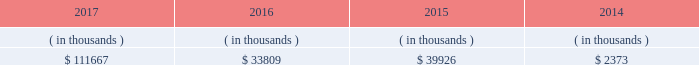System energy may refinance , redeem , or otherwise retire debt prior to maturity , to the extent market conditions and interest and dividend rates are favorable .
All debt and common stock issuances by system energy require prior regulatory approval . a0 a0debt issuances are also subject to issuance tests set forth in its bond indentures and other agreements . a0 a0system energy has sufficient capacity under these tests to meet its foreseeable capital needs .
System energy 2019s receivables from the money pool were as follows as of december 31 for each of the following years. .
See note 4 to the financial statements for a description of the money pool .
The system energy nuclear fuel company variable interest entity has a credit facility in the amount of $ 120 million scheduled to expire in may 2019 .
As of december 31 , 2017 , $ 17.8 million in letters of credit to support a like amount of commercial paper issued and $ 50 million in loans were outstanding under the system energy nuclear fuel company variable interest entity credit facility .
See note 4 to the financial statements for additional discussion of the variable interest entity credit facility .
System energy obtained authorizations from the ferc through october 2019 for the following : 2022 short-term borrowings not to exceed an aggregate amount of $ 200 million at any time outstanding ; 2022 long-term borrowings and security issuances ; and 2022 long-term borrowings by its nuclear fuel company variable interest entity .
See note 4 to the financial statements for further discussion of system energy 2019s short-term borrowing limits .
System energy resources , inc .
Management 2019s financial discussion and analysis federal regulation see the 201crate , cost-recovery , and other regulation 2013 federal regulation 201d section of entergy corporation and subsidiaries management 2019s financial discussion and analysis and note 2 to the financial statements for a discussion of federal regulation .
Complaint against system energy in january 2017 the apsc and mpsc filed a complaint with the ferc against system energy .
The complaint seeks a reduction in the return on equity component of the unit power sales agreement pursuant to which system energy sells its grand gulf capacity and energy to entergy arkansas , entergy louisiana , entergy mississippi , and entergy new orleans .
Entergy arkansas also sells some of its grand gulf capacity and energy to entergy louisiana , entergy mississippi , and entergy new orleans under separate agreements .
The current return on equity under the unit power sales agreement is 10.94% ( 10.94 % ) .
The complaint alleges that the return on equity is unjust and unreasonable because current capital market and other considerations indicate that it is excessive .
The complaint requests the ferc to institute proceedings to investigate the return on equity and establish a lower return on equity , and also requests that the ferc establish january 23 , 2017 as a refund effective date .
The complaint includes return on equity analysis that purports to establish that the range of reasonable return on equity for system energy is between 8.37% ( 8.37 % ) and 8.67% ( 8.67 % ) .
System energy answered the complaint in february 2017 and disputes that a return on equity of 8.37% ( 8.37 % ) to 8.67% ( 8.67 % ) is just and reasonable .
The lpsc and the city council intervened in the proceeding expressing support for the complaint .
System energy is recording a provision against revenue for the potential outcome of this proceeding .
In september 2017 the ferc established a refund effective date of january 23 , 2017 , consolidated the return on equity complaint with the proceeding described in unit power sales agreement below , and directed the parties to engage in settlement .
What percent of short term borrowing allowance was outstanding in 2017? 
Computations: ((17.8 + 50) / 200)
Answer: 0.339. 